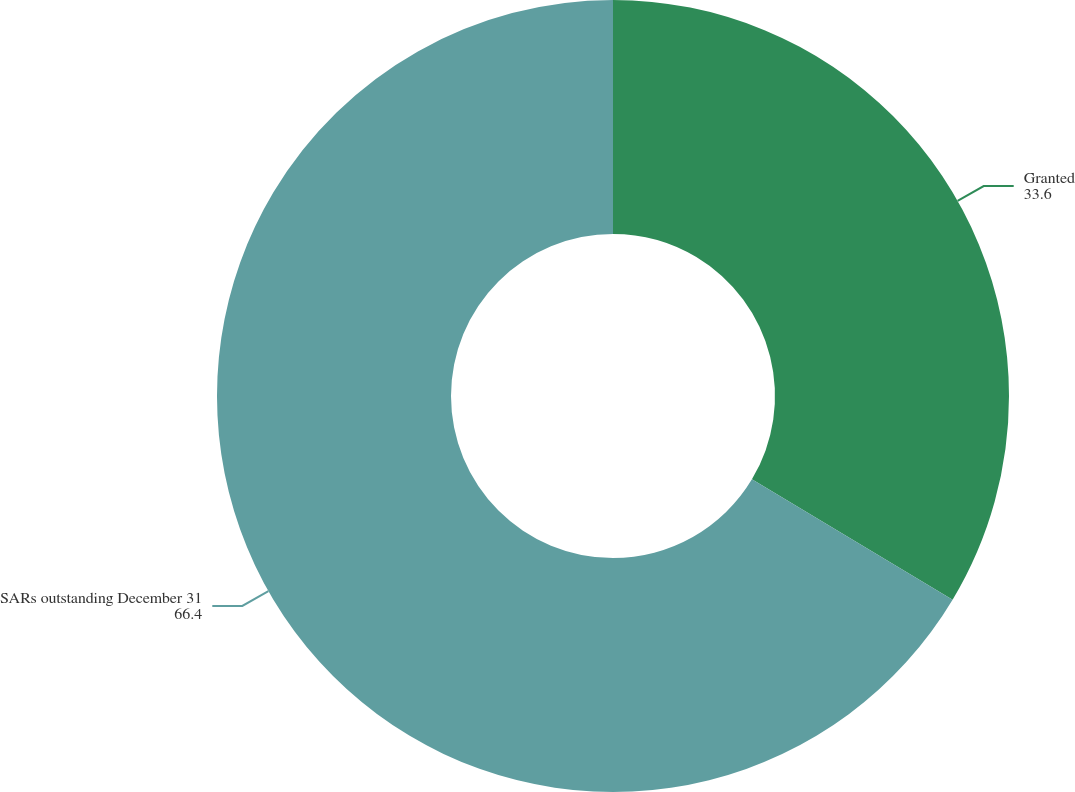<chart> <loc_0><loc_0><loc_500><loc_500><pie_chart><fcel>Granted<fcel>SARs outstanding December 31<nl><fcel>33.6%<fcel>66.4%<nl></chart> 